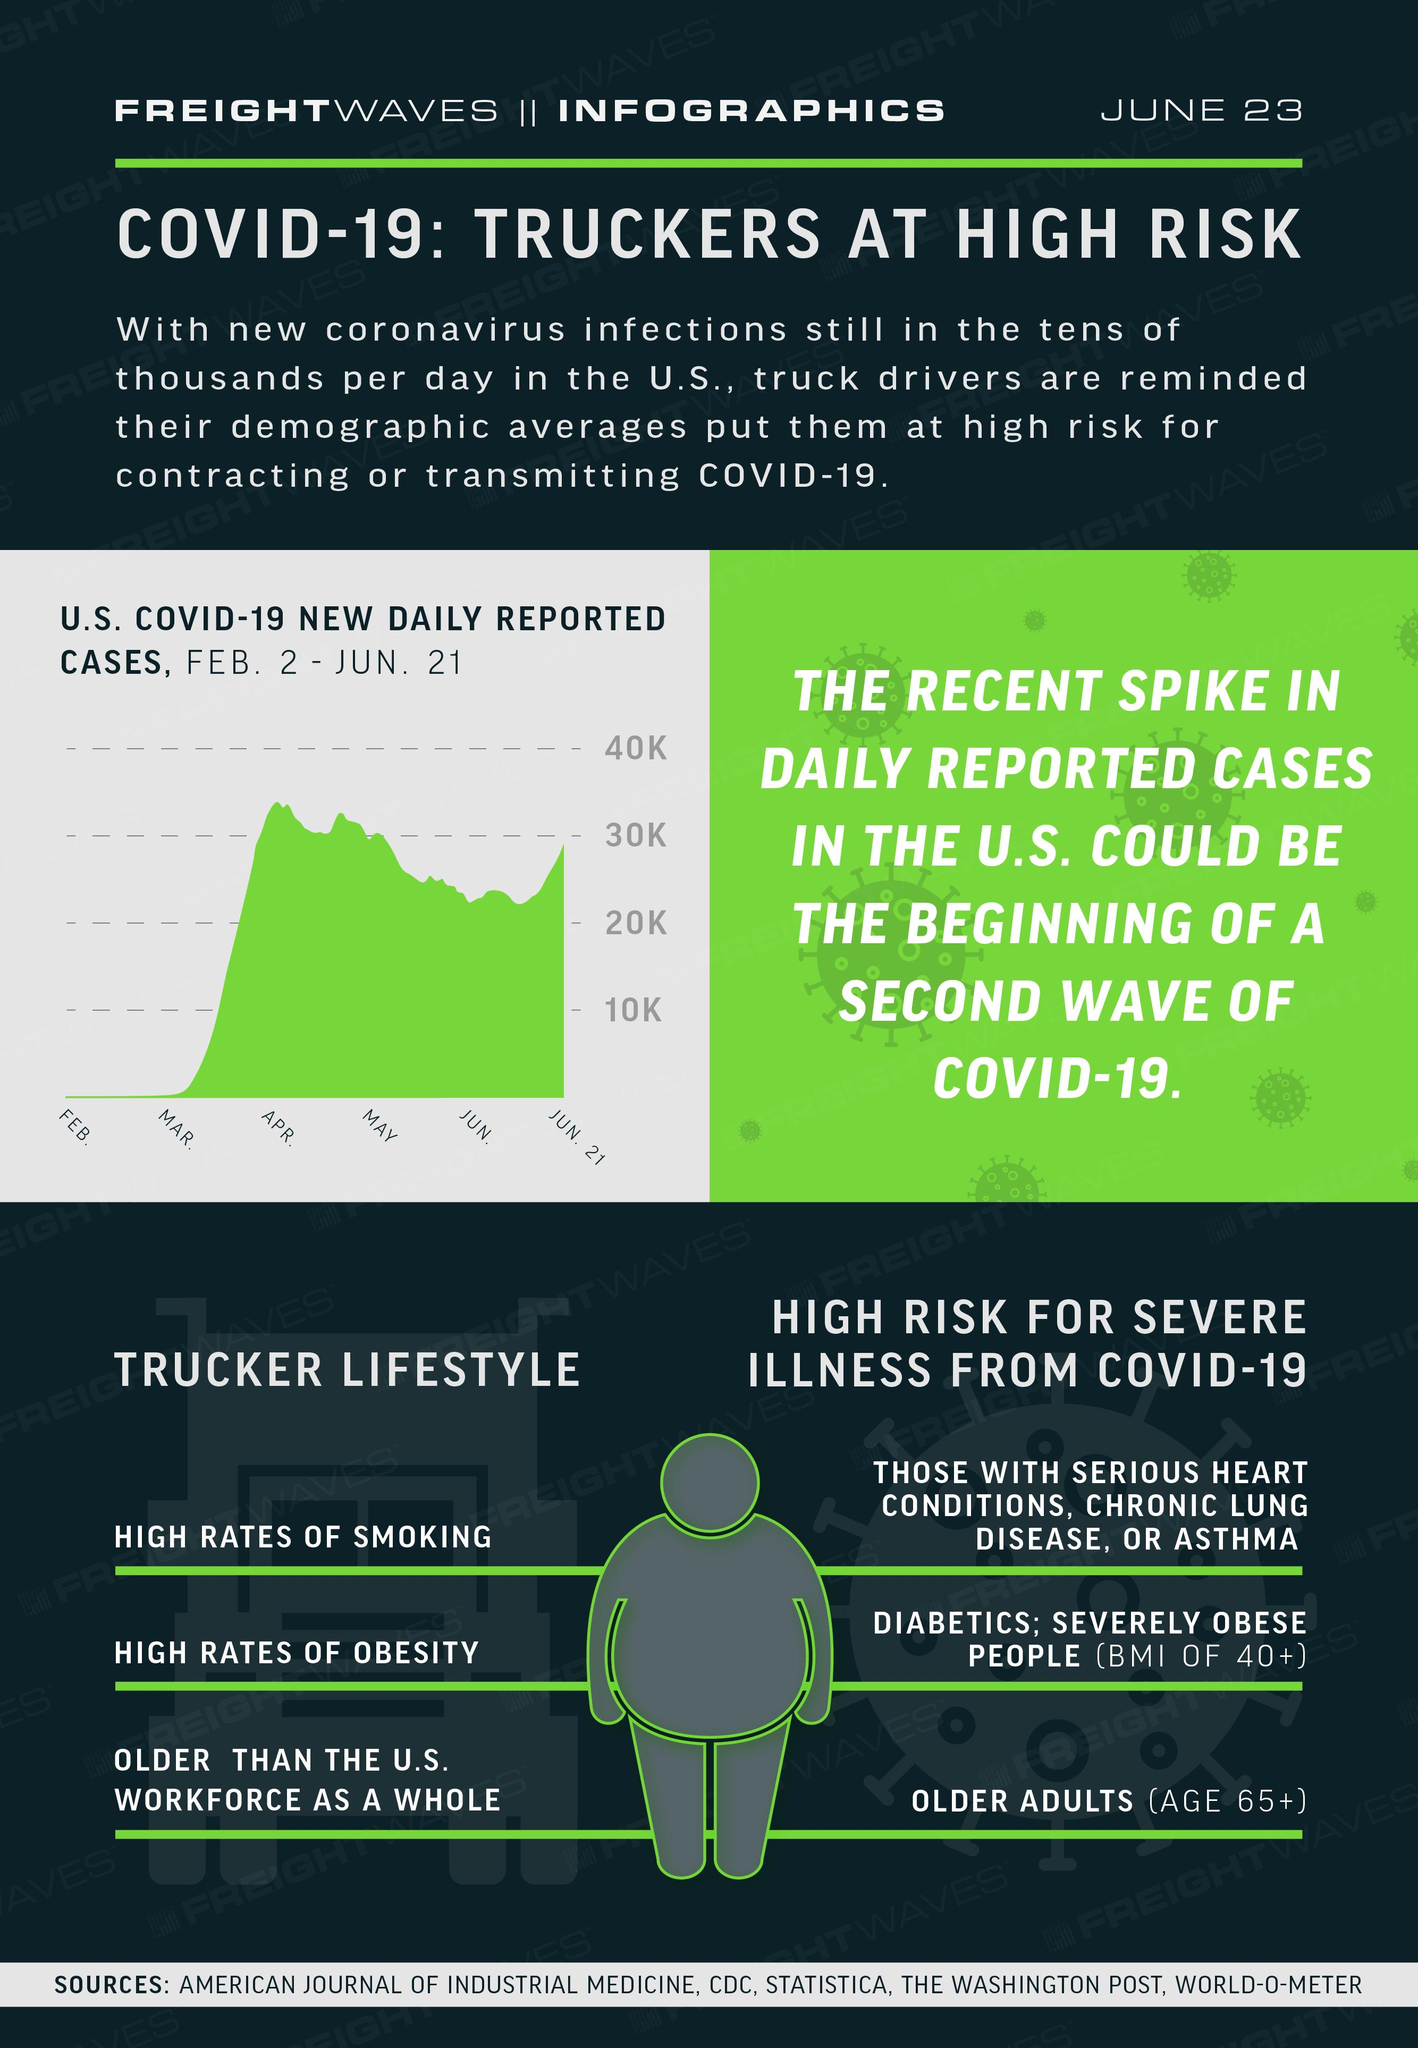Mention a couple of crucial points in this snapshot. It is reported that individuals with preexisting conditions such as serious heart conditions, chronic lung disease, or asthma are at a higher risk of experiencing severe illness from COVID-19. The risk of severe illness from COVID-19 is particularly high for older adults, who may have weakened immune systems and other health conditions that make them more vulnerable to the virus. The lifestyle choices of truckers, such as smoking and obesity, have been shown to be associated with higher rates of certain health conditions. 